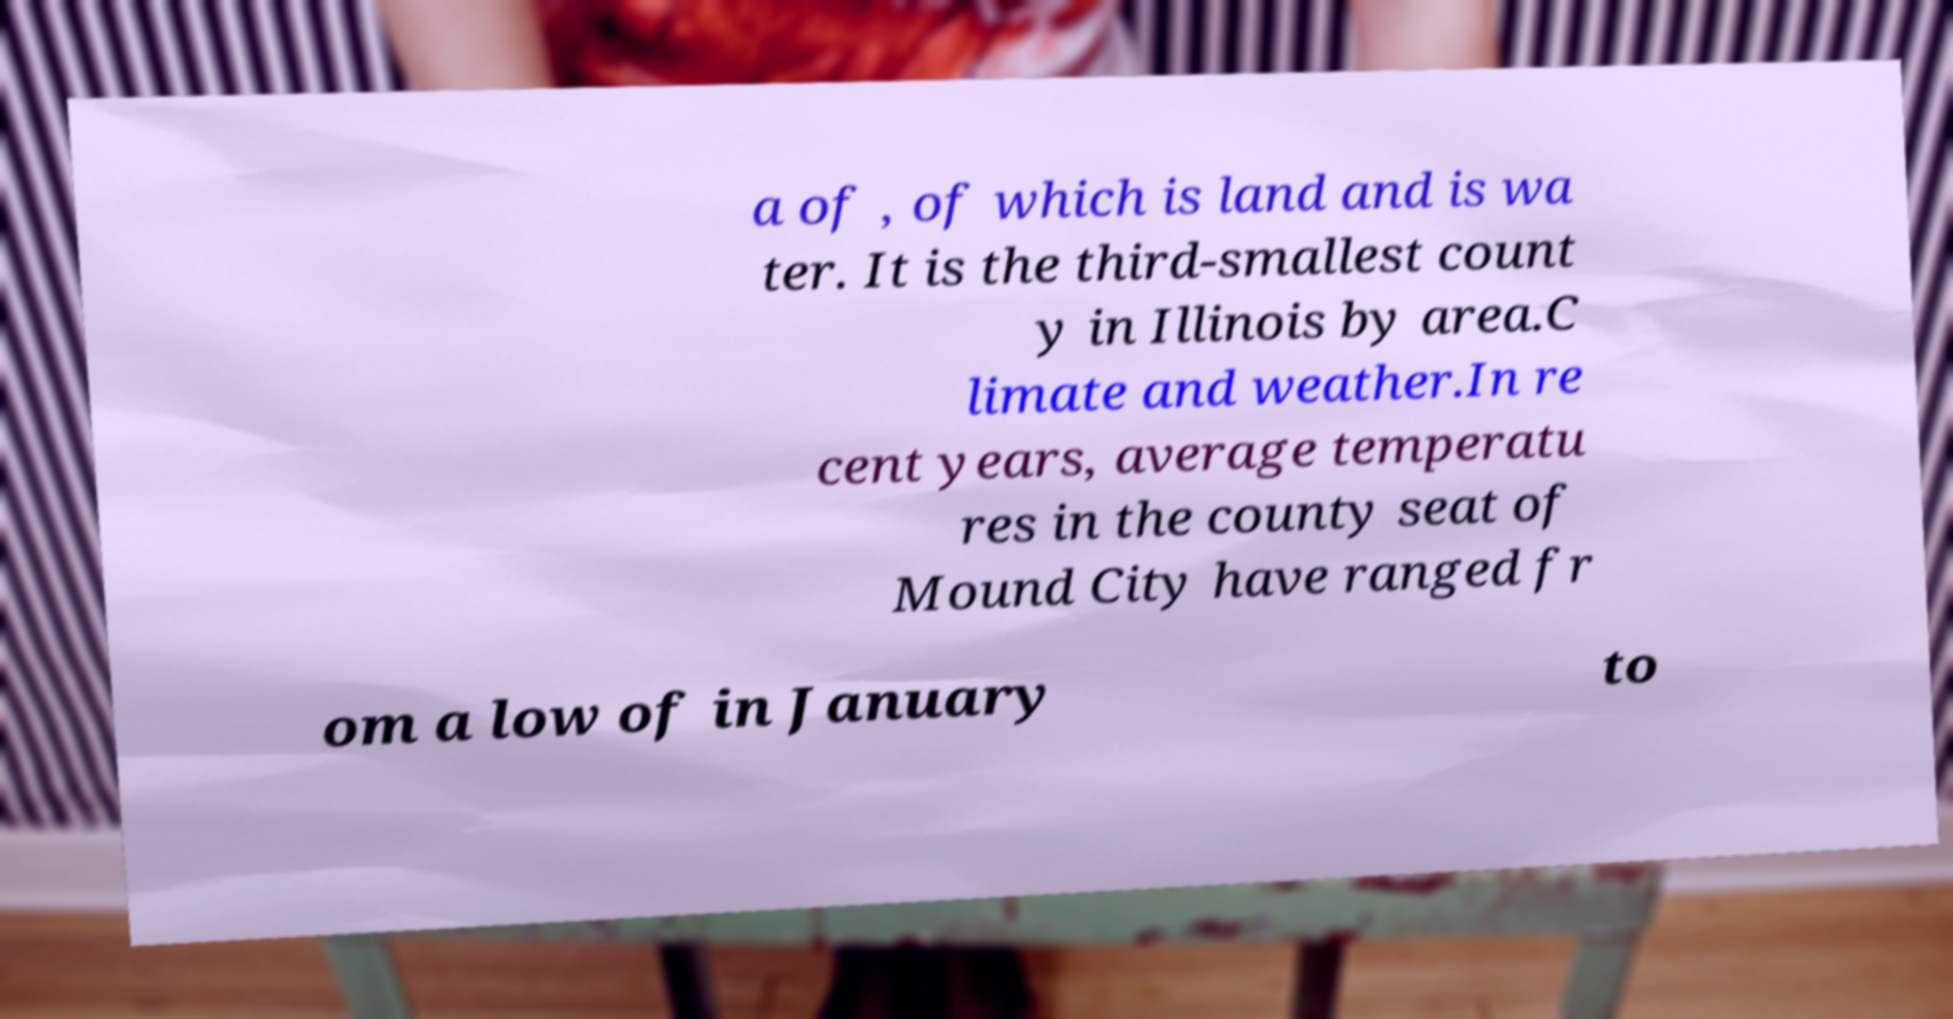What messages or text are displayed in this image? I need them in a readable, typed format. a of , of which is land and is wa ter. It is the third-smallest count y in Illinois by area.C limate and weather.In re cent years, average temperatu res in the county seat of Mound City have ranged fr om a low of in January to 